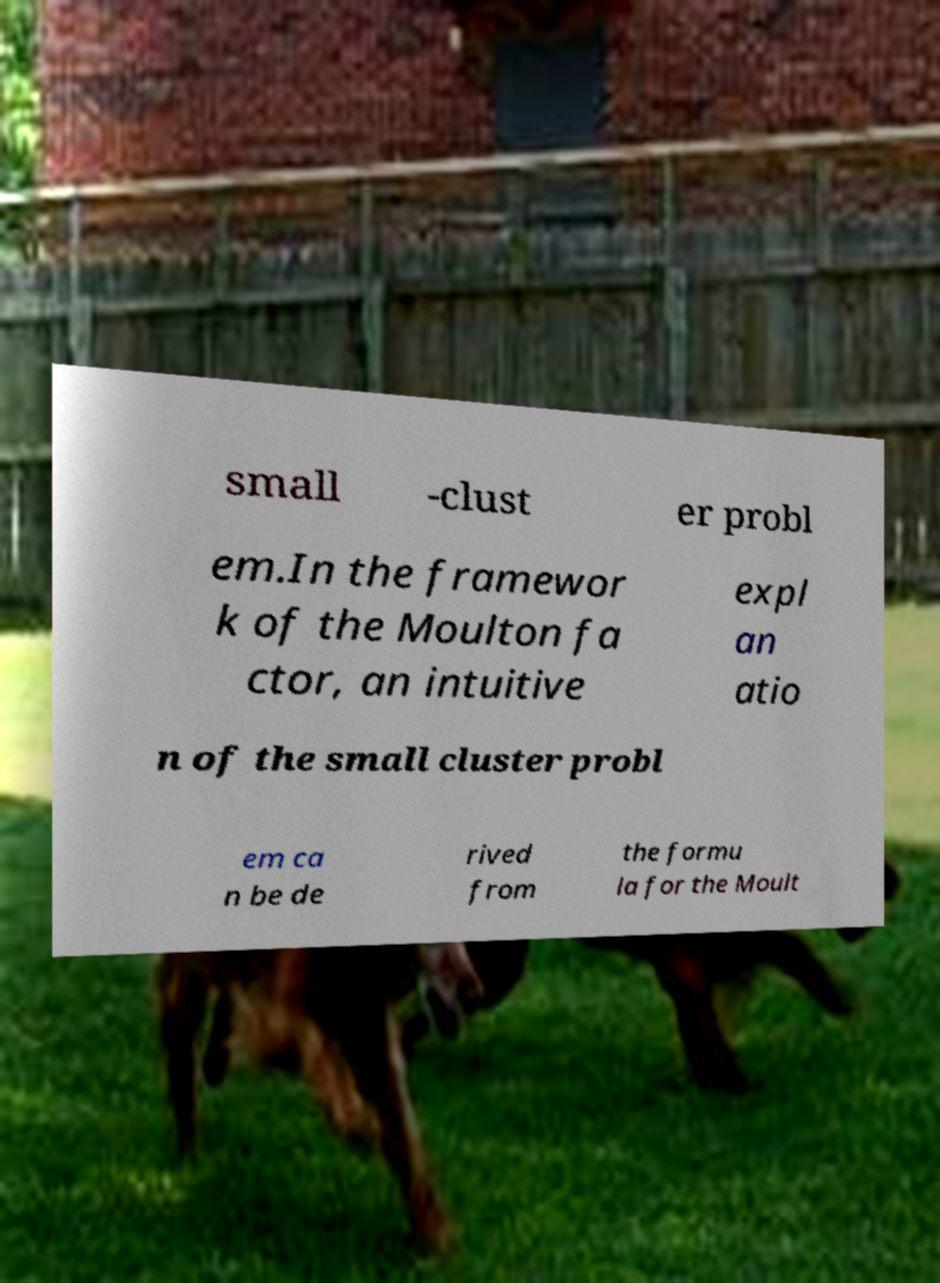Can you accurately transcribe the text from the provided image for me? small -clust er probl em.In the framewor k of the Moulton fa ctor, an intuitive expl an atio n of the small cluster probl em ca n be de rived from the formu la for the Moult 